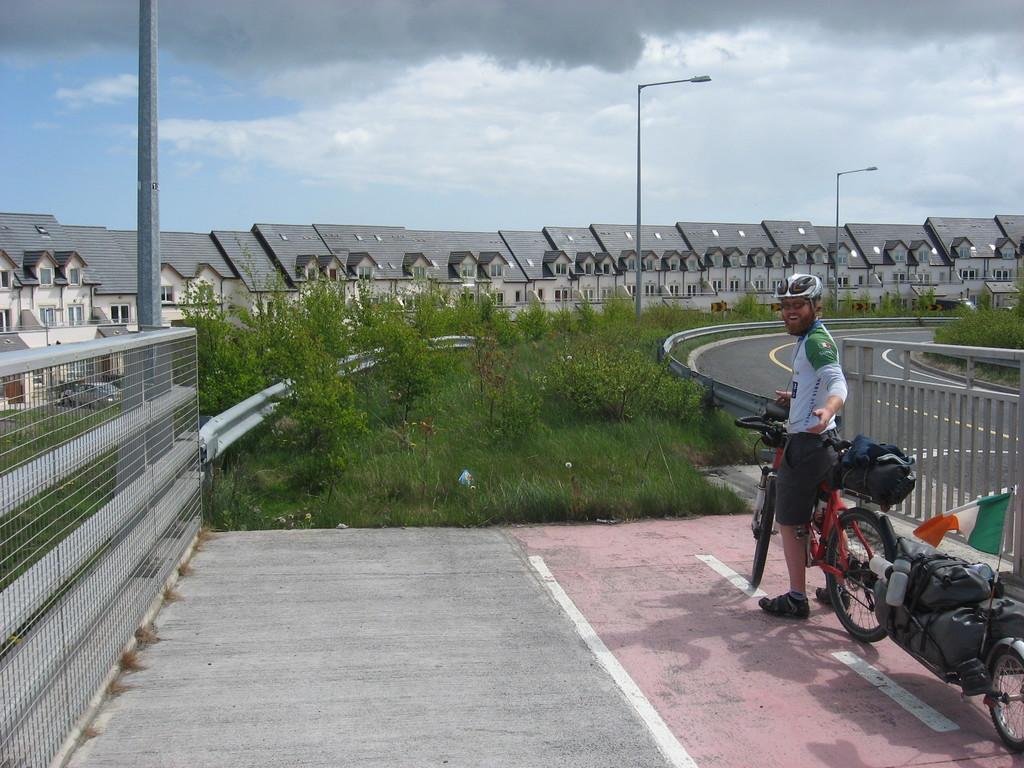In one or two sentences, can you explain what this image depicts? In this picture, here we can see a person who is smiling and he is having bicycle, on the bicycle we have some bag and this person wears helmet. He is standing on footpath present beside road. And in the background, we can see some buildings, street light poles and on the top we can see sky with clouds. And a flag is also present at the bottom right of the picture. 